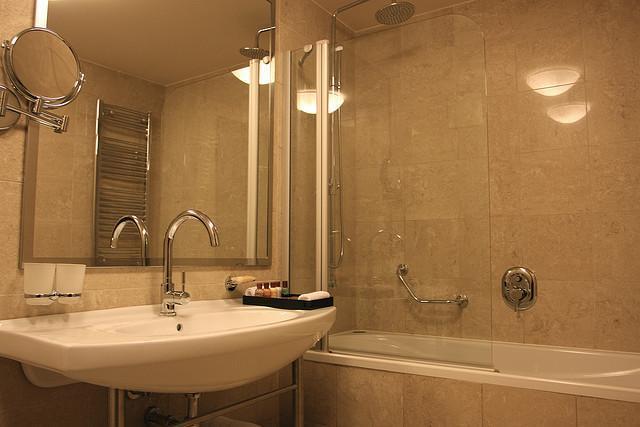How many mirror are in this picture?
Give a very brief answer. 2. How many sinks can you see?
Give a very brief answer. 1. How many giraffes are there?
Give a very brief answer. 0. 